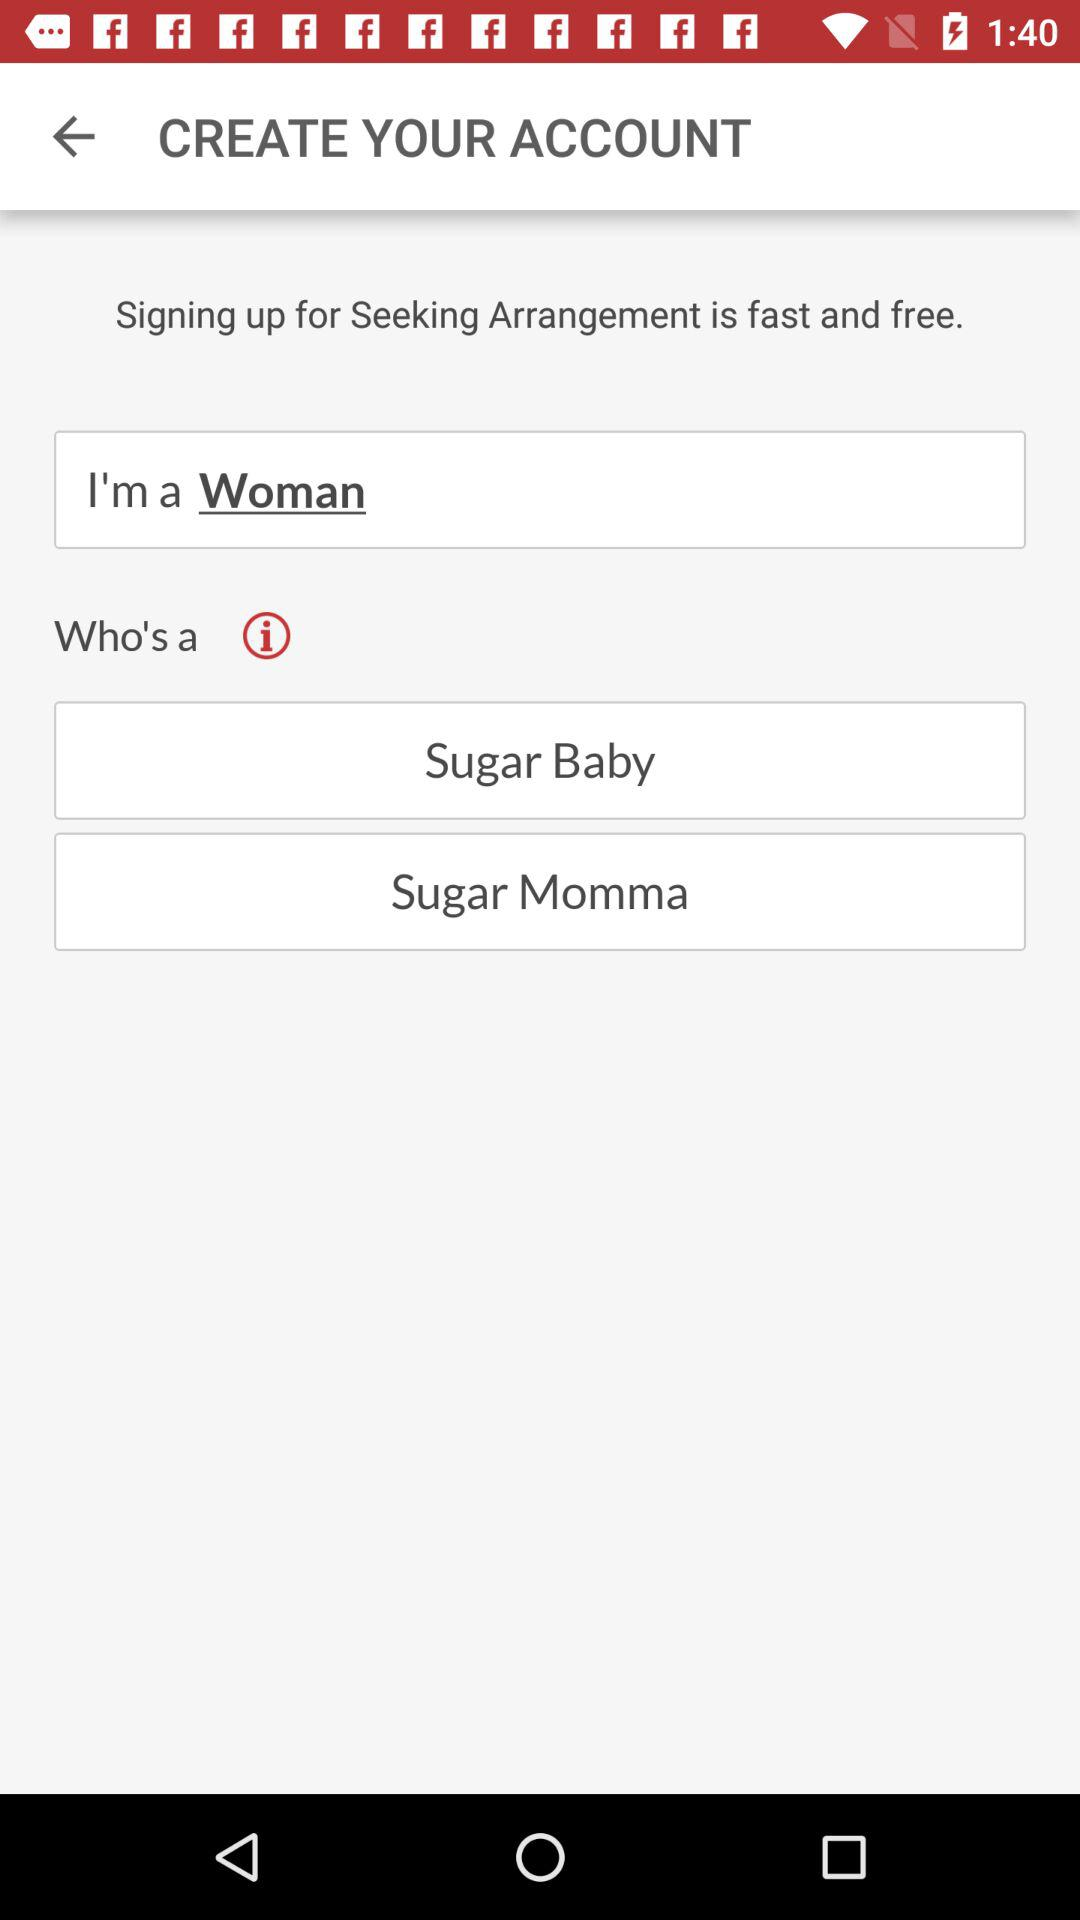What is the gender? The user is a woman. 